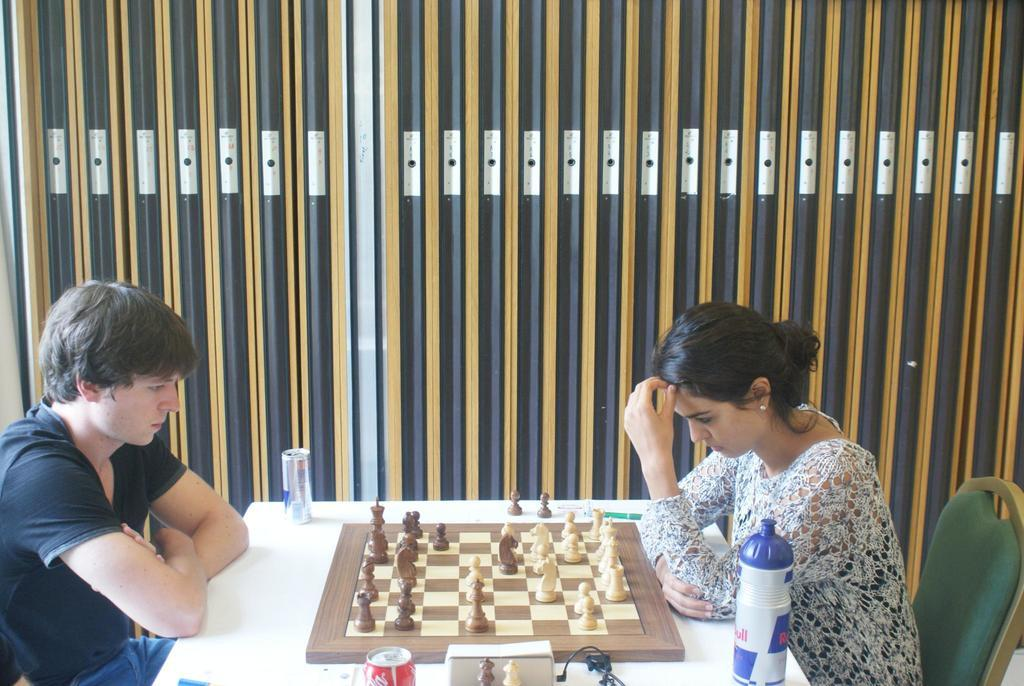How many people are in the image? There are two people in the image, a man and a woman. What are the man and woman doing in the image? They are playing chess in the image. Where are the man and woman sitting? They are sitting on chairs in the image. What is the chess board placed on? The chess board is placed on a table in the image. What other objects can be seen on the table? There is a tin and a bottle on the table in the image. What is visible in the background of the image? There is a wall visible in the image. How many rabbits are playing chess with the man and woman in the image? There are no rabbits present in the image; it is the man and woman playing chess together. What type of recess is shown in the image? There is no recess depicted in the image; it features a man and woman playing chess. 